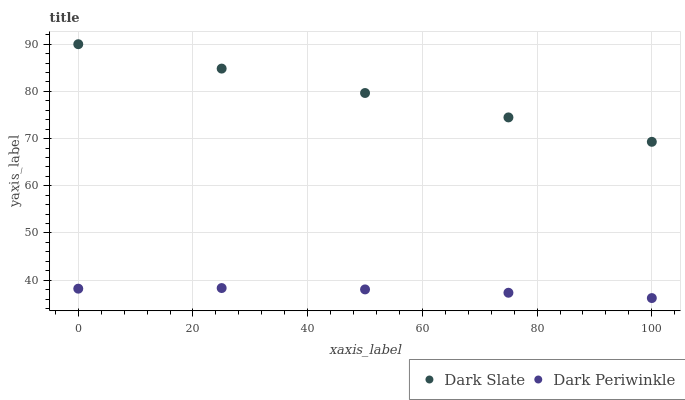Does Dark Periwinkle have the minimum area under the curve?
Answer yes or no. Yes. Does Dark Slate have the maximum area under the curve?
Answer yes or no. Yes. Does Dark Periwinkle have the maximum area under the curve?
Answer yes or no. No. Is Dark Slate the smoothest?
Answer yes or no. Yes. Is Dark Periwinkle the roughest?
Answer yes or no. Yes. Is Dark Periwinkle the smoothest?
Answer yes or no. No. Does Dark Periwinkle have the lowest value?
Answer yes or no. Yes. Does Dark Slate have the highest value?
Answer yes or no. Yes. Does Dark Periwinkle have the highest value?
Answer yes or no. No. Is Dark Periwinkle less than Dark Slate?
Answer yes or no. Yes. Is Dark Slate greater than Dark Periwinkle?
Answer yes or no. Yes. Does Dark Periwinkle intersect Dark Slate?
Answer yes or no. No. 